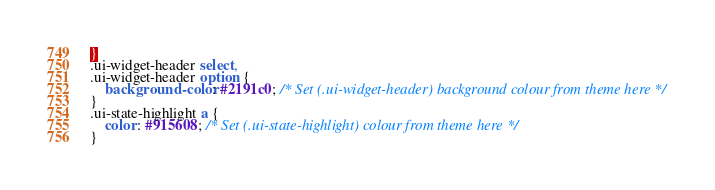<code> <loc_0><loc_0><loc_500><loc_500><_CSS_>}
.ui-widget-header select,
.ui-widget-header option {
	background-color: #2191c0; /* Set (.ui-widget-header) background colour from theme here */
}
.ui-state-highlight a {
	color: #915608; /* Set (.ui-state-highlight) colour from theme here */
}
</code> 